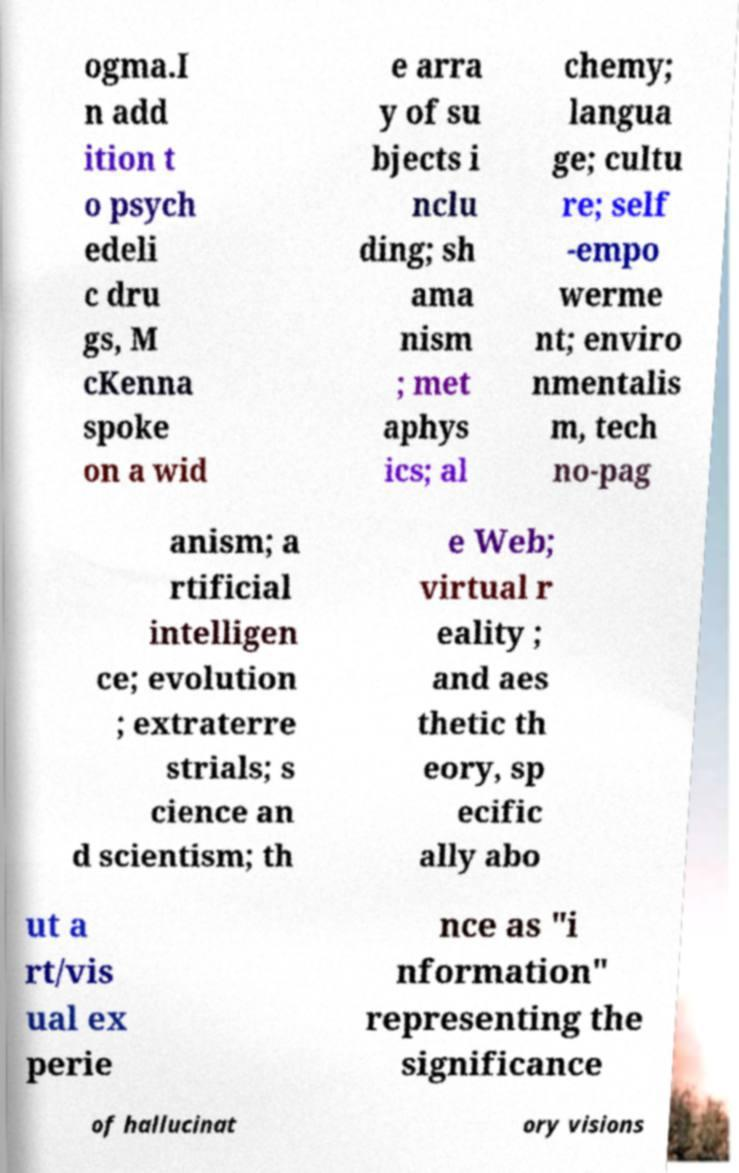Could you extract and type out the text from this image? ogma.I n add ition t o psych edeli c dru gs, M cKenna spoke on a wid e arra y of su bjects i nclu ding; sh ama nism ; met aphys ics; al chemy; langua ge; cultu re; self -empo werme nt; enviro nmentalis m, tech no-pag anism; a rtificial intelligen ce; evolution ; extraterre strials; s cience an d scientism; th e Web; virtual r eality ; and aes thetic th eory, sp ecific ally abo ut a rt/vis ual ex perie nce as "i nformation" representing the significance of hallucinat ory visions 